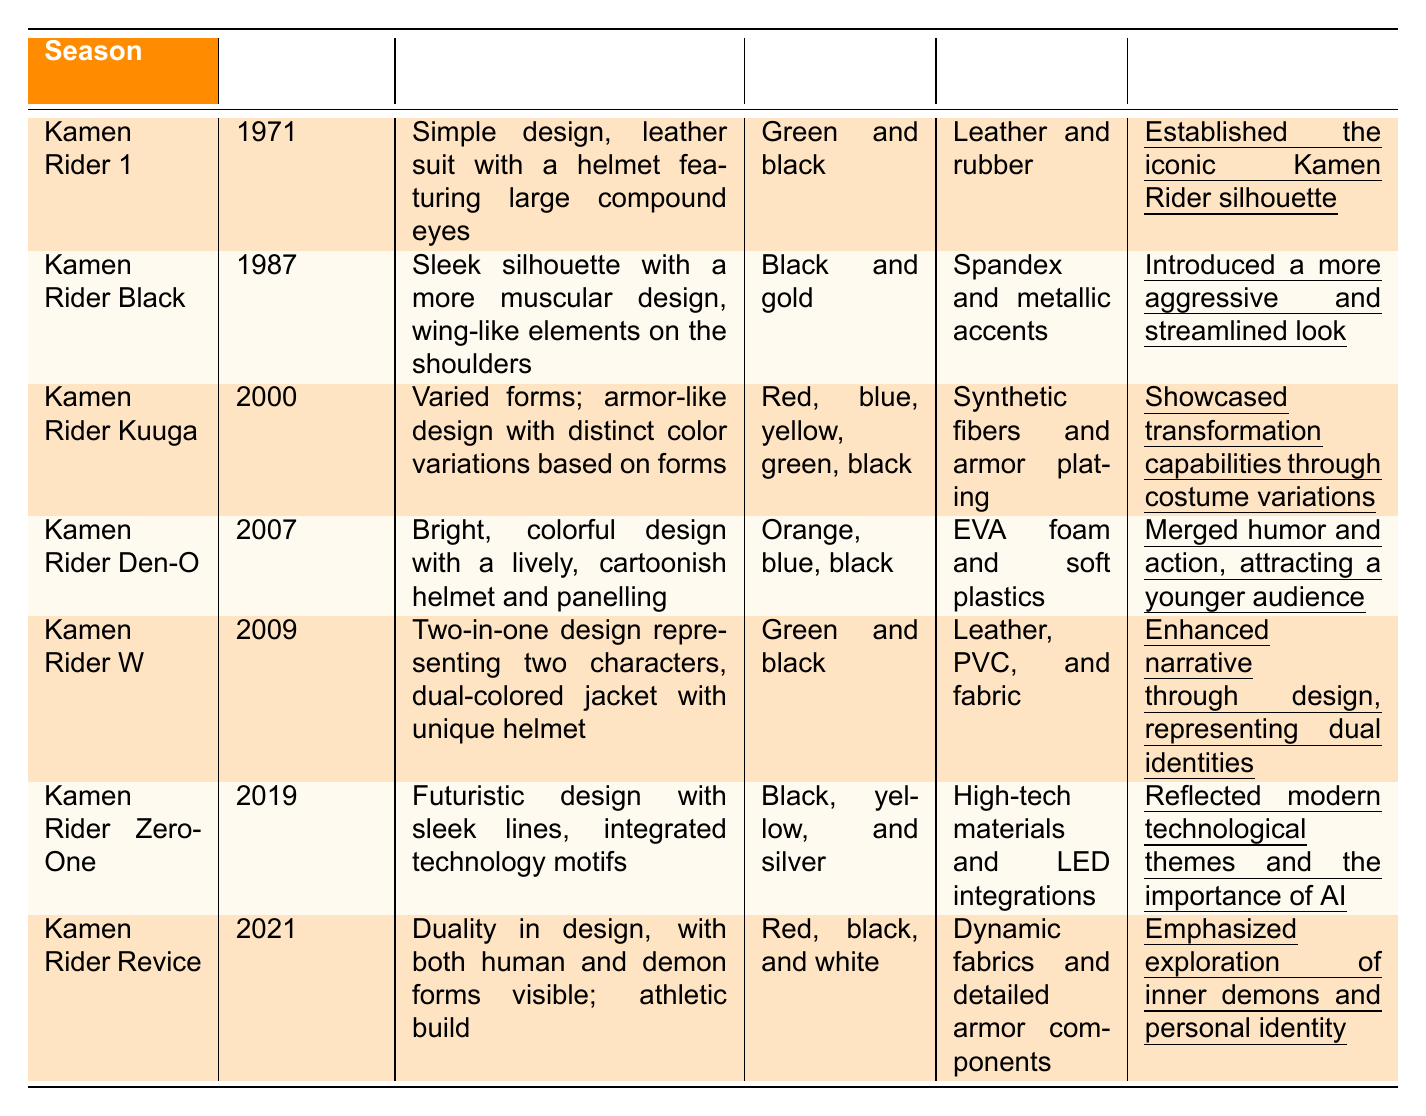What is the color palette of Kamen Rider Kuuga? The color palette for Kamen Rider Kuuga is listed as red, blue, yellow, green, and black in the table.
Answer: Red, blue, yellow, green, black Which season introduced a costume with wing-like elements? The table shows that Kamen Rider Black, which aired in 1987, features a sleek silhouette with wing-like elements on the shoulders.
Answer: Kamen Rider Black What materials were used in the costume design of Kamen Rider Revice? According to the table, the materials used for Kamen Rider Revice include dynamic fabrics and detailed armor components.
Answer: Dynamic fabrics and detailed armor components Which Kamen Rider season's design is described as having a lively, cartoonish helmet? Referring to the table, Kamen Rider Den-O's costume design is characterized by a bright, colorful design and a lively, cartoonish helmet.
Answer: Kamen Rider Den-O How many seasons use the color black in their color palette? By counting the occurrences in the table, Kamen Rider Black, Kamen Rider W, Kamen Rider Zero-One, and Kamen Rider Revice all have black in their palettes, totaling four seasons.
Answer: 4 Which costume from the table emphasized modern technological themes? The table specifies that Kamen Rider Zero-One has a futuristic design that incorporates sleek lines and technology motifs, reflecting modern technological themes.
Answer: Kamen Rider Zero-One What are the main materials used in Kamen Rider W's costume? From the table, the materials used for Kamen Rider W are leather, PVC, and fabric, listed under the respective column.
Answer: Leather, PVC, and fabric Did the Kamen Rider series evolve to showcase dual identities? Yes, according to the table, Kamen Rider W is noted for its design that represents dual identities, indicating an evolution in costume design to reflect narrative themes.
Answer: Yes What is the significance of Kamen Rider Den-O's costume design? The table states that Kamen Rider Den-O's costumes merged humor and action, appealing to a younger audience, highlighting its significance.
Answer: Merged humor and action Which season has a costume that features both human and demon forms? The table mentions that Kamen Rider Revice showcases dual designs representing human and demon forms, thus answering the question.
Answer: Kamen Rider Revice 